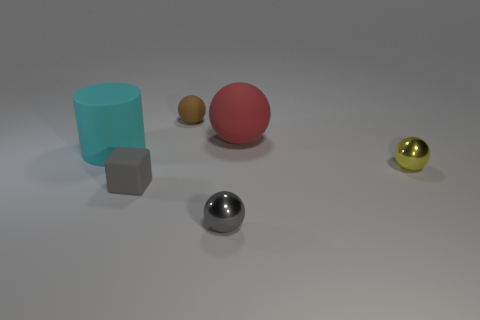There is a small brown thing; what shape is it?
Offer a terse response. Sphere. Are there more tiny gray balls that are in front of the big cyan thing than cyan blocks?
Provide a succinct answer. Yes. Are there any other things that have the same shape as the cyan thing?
Offer a very short reply. No. What is the color of the other small metal object that is the same shape as the yellow shiny object?
Give a very brief answer. Gray. What is the shape of the big object that is behind the big cyan object?
Your response must be concise. Sphere. Are there any small balls left of the yellow sphere?
Make the answer very short. Yes. There is a cylinder that is made of the same material as the large red ball; what is its color?
Ensure brevity in your answer.  Cyan. Is the color of the small metallic thing in front of the tiny block the same as the matte thing in front of the small yellow object?
Your answer should be very brief. Yes. How many balls are either tiny gray things or red rubber objects?
Offer a very short reply. 2. Is the number of matte objects on the left side of the red sphere the same as the number of small balls?
Give a very brief answer. Yes. 